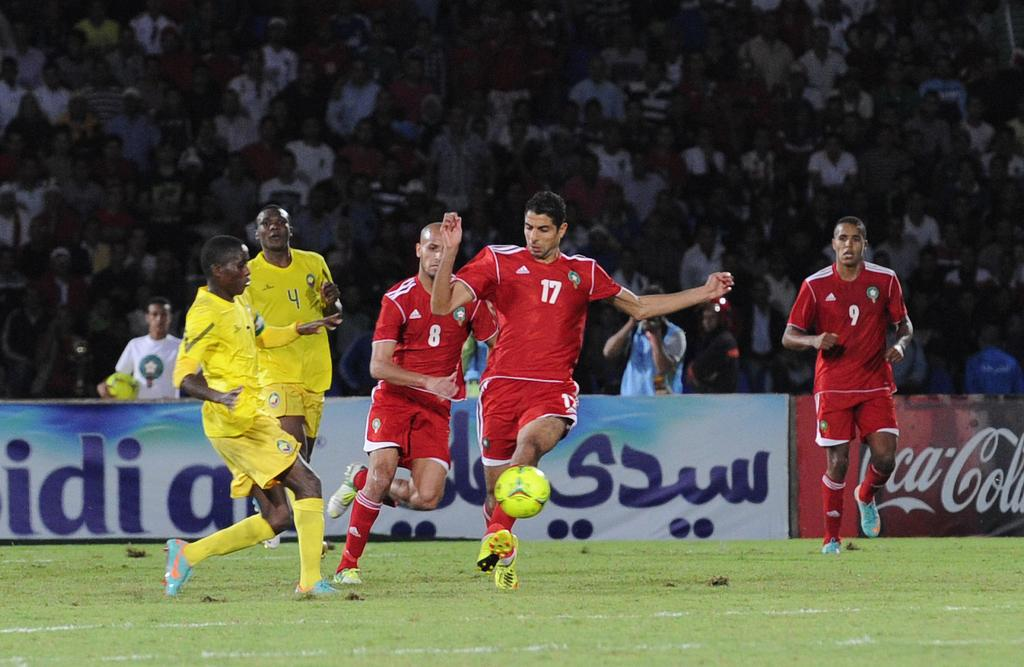<image>
Summarize the visual content of the image. Player number 17 in red kicks a soccer ball aiming for the goal. 